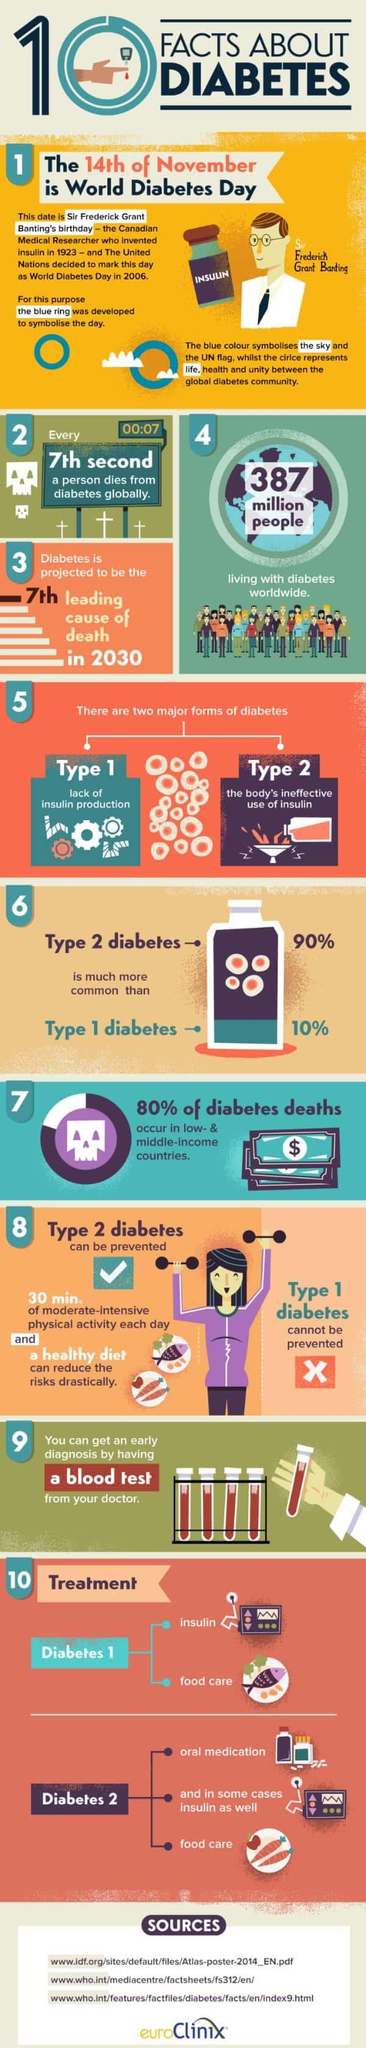Draw attention to some important aspects in this diagram. According to a recent study, approximately 90% of people are not affected by Type 1 diabetes. The total population of diabetic people in the world is 387 million people. Type 2 diabetes is a condition in which oral medication is used as one of the treatment options. Type 1 Diabetes is treated with two primary methods: insulin therapy and food management. Type 1 diabetes is caused by a lack of insulin production in the body. 